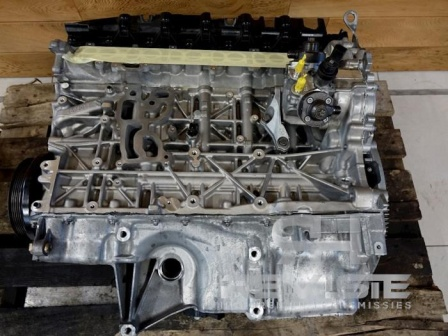Envision this engine block as an integral part of an advanced AI system in a futuristic vehicle. Describe its role and functionalities in this new context. In a futuristic vehicle equipped with advanced AI, this engine block could be reimagined as the core of a highly efficient and intelligent powertrain. Integrated with sensors and smart diagnostics, the AI could monitor every aspect of engine performance in real-time, optimizing fuel efficiency and power output based on driving conditions. The engine block could house advanced materials and technologies, such as self-healing metals and adaptive cooling systems, ensuring its longevity and reliability. The AI, learning from millions of data points, could anticipate and prevent potential issues, scheduling maintenance proactively. This harmonious blend of mechanical engineering and artificial intelligence would mark a new era in automotive innovation, where the engine is not just a power source but a smart, adaptive component that enhances every journey. How would the integration of AI enhance the safety features of the vehicle? The integration of AI into the vehicle's systems could dramatically enhance safety features. The AI could process data from various sensors to detect potential hazards in real-time, such as obstacles, erratic behavior from other drivers, and adverse weather conditions. It could also predict and respond to mechanical issues before they lead to failures, reducing the risk of accidents. The AI could assist in emergency maneuvers, such as automatic braking and steering adjustments, to avoid collisions. Overall, the fusion of AI technology with traditional automotive components would create a safer, more responsive driving experience, protecting passengers and enhancing road safety. 